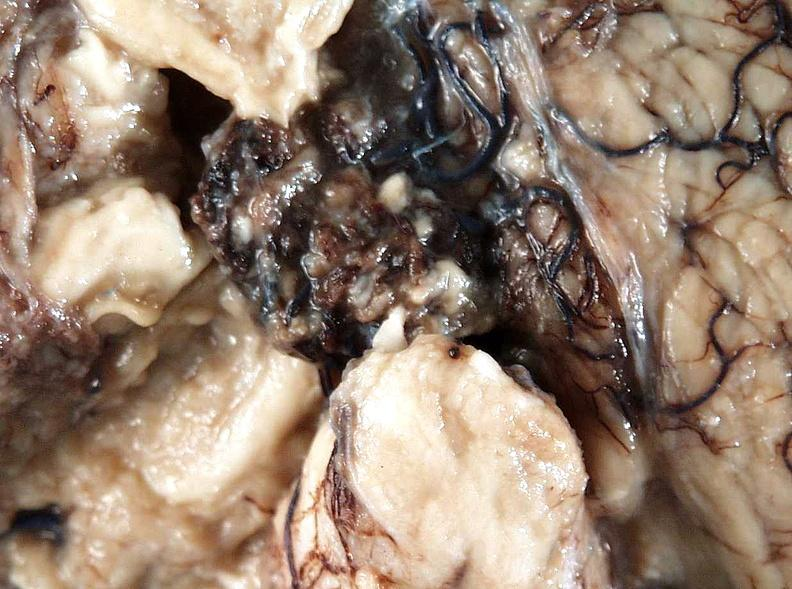s nervous present?
Answer the question using a single word or phrase. Yes 